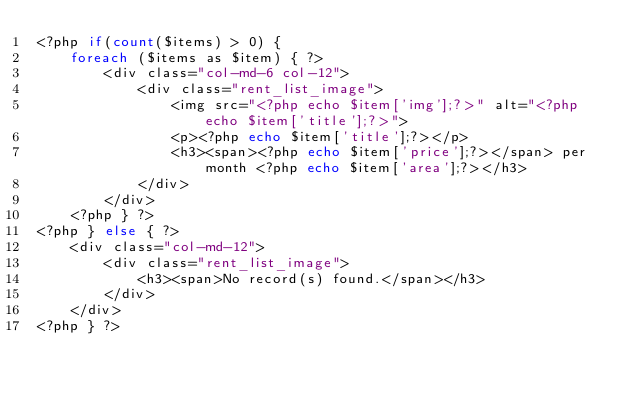Convert code to text. <code><loc_0><loc_0><loc_500><loc_500><_PHP_><?php if(count($items) > 0) {
    foreach ($items as $item) { ?>
        <div class="col-md-6 col-12">
            <div class="rent_list_image">
                <img src="<?php echo $item['img'];?>" alt="<?php echo $item['title'];?>">
                <p><?php echo $item['title'];?></p>
                <h3><span><?php echo $item['price'];?></span> per month <?php echo $item['area'];?></h3>
            </div>
        </div>
    <?php } ?>
<?php } else { ?>
    <div class="col-md-12">
        <div class="rent_list_image">
            <h3><span>No record(s) found.</span></h3>
        </div>
    </div>
<?php } ?>
</code> 